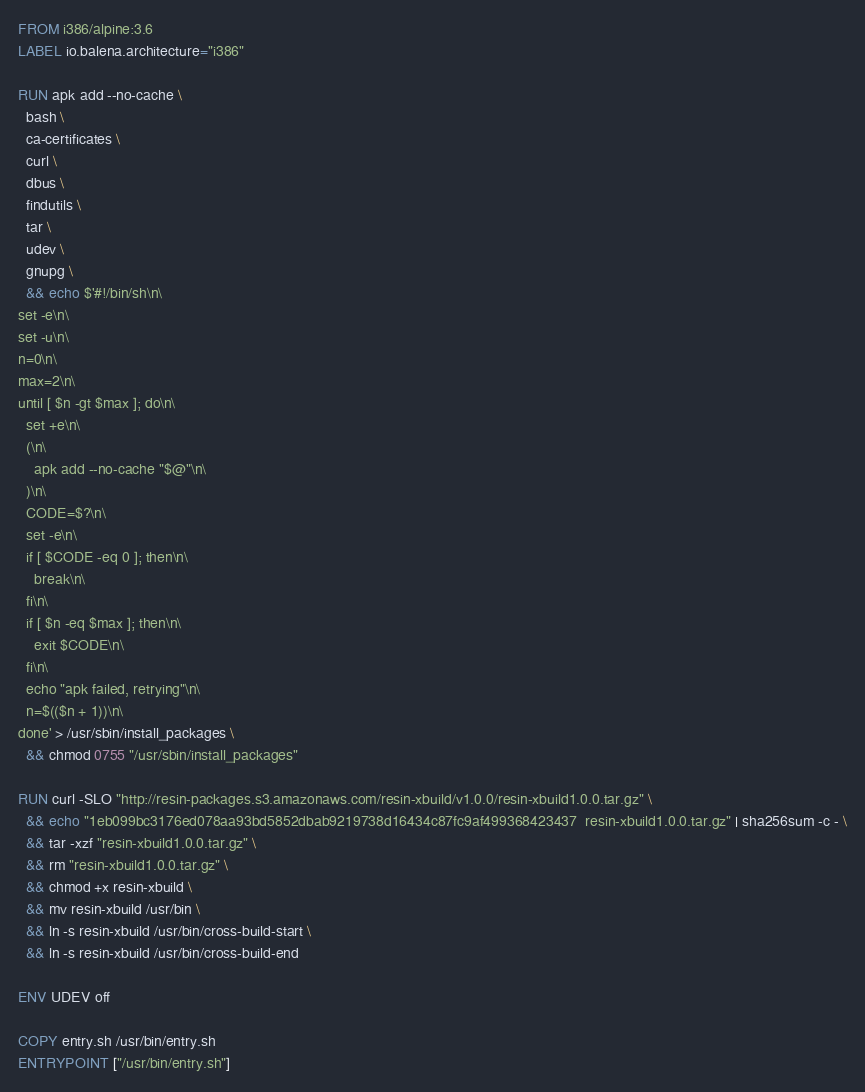Convert code to text. <code><loc_0><loc_0><loc_500><loc_500><_Dockerfile_>FROM i386/alpine:3.6
LABEL io.balena.architecture="i386"

RUN apk add --no-cache \
  bash \
  ca-certificates \
  curl \
  dbus \
  findutils \
  tar \
  udev \
  gnupg \
  && echo $'#!/bin/sh\n\
set -e\n\
set -u\n\
n=0\n\
max=2\n\
until [ $n -gt $max ]; do\n\
  set +e\n\
  (\n\
    apk add --no-cache "$@"\n\
  )\n\
  CODE=$?\n\
  set -e\n\
  if [ $CODE -eq 0 ]; then\n\
    break\n\
  fi\n\
  if [ $n -eq $max ]; then\n\
    exit $CODE\n\
  fi\n\
  echo "apk failed, retrying"\n\
  n=$(($n + 1))\n\
done' > /usr/sbin/install_packages \
  && chmod 0755 "/usr/sbin/install_packages"

RUN curl -SLO "http://resin-packages.s3.amazonaws.com/resin-xbuild/v1.0.0/resin-xbuild1.0.0.tar.gz" \
  && echo "1eb099bc3176ed078aa93bd5852dbab9219738d16434c87fc9af499368423437  resin-xbuild1.0.0.tar.gz" | sha256sum -c - \
  && tar -xzf "resin-xbuild1.0.0.tar.gz" \
  && rm "resin-xbuild1.0.0.tar.gz" \
  && chmod +x resin-xbuild \
  && mv resin-xbuild /usr/bin \
  && ln -s resin-xbuild /usr/bin/cross-build-start \
  && ln -s resin-xbuild /usr/bin/cross-build-end

ENV UDEV off

COPY entry.sh /usr/bin/entry.sh
ENTRYPOINT ["/usr/bin/entry.sh"]</code> 